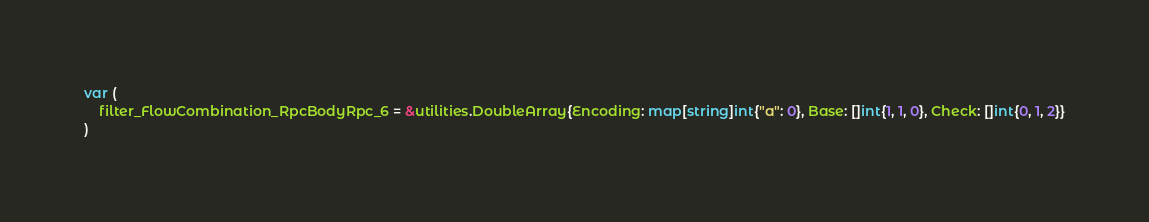Convert code to text. <code><loc_0><loc_0><loc_500><loc_500><_Go_>var (
	filter_FlowCombination_RpcBodyRpc_6 = &utilities.DoubleArray{Encoding: map[string]int{"a": 0}, Base: []int{1, 1, 0}, Check: []int{0, 1, 2}}
)
</code> 